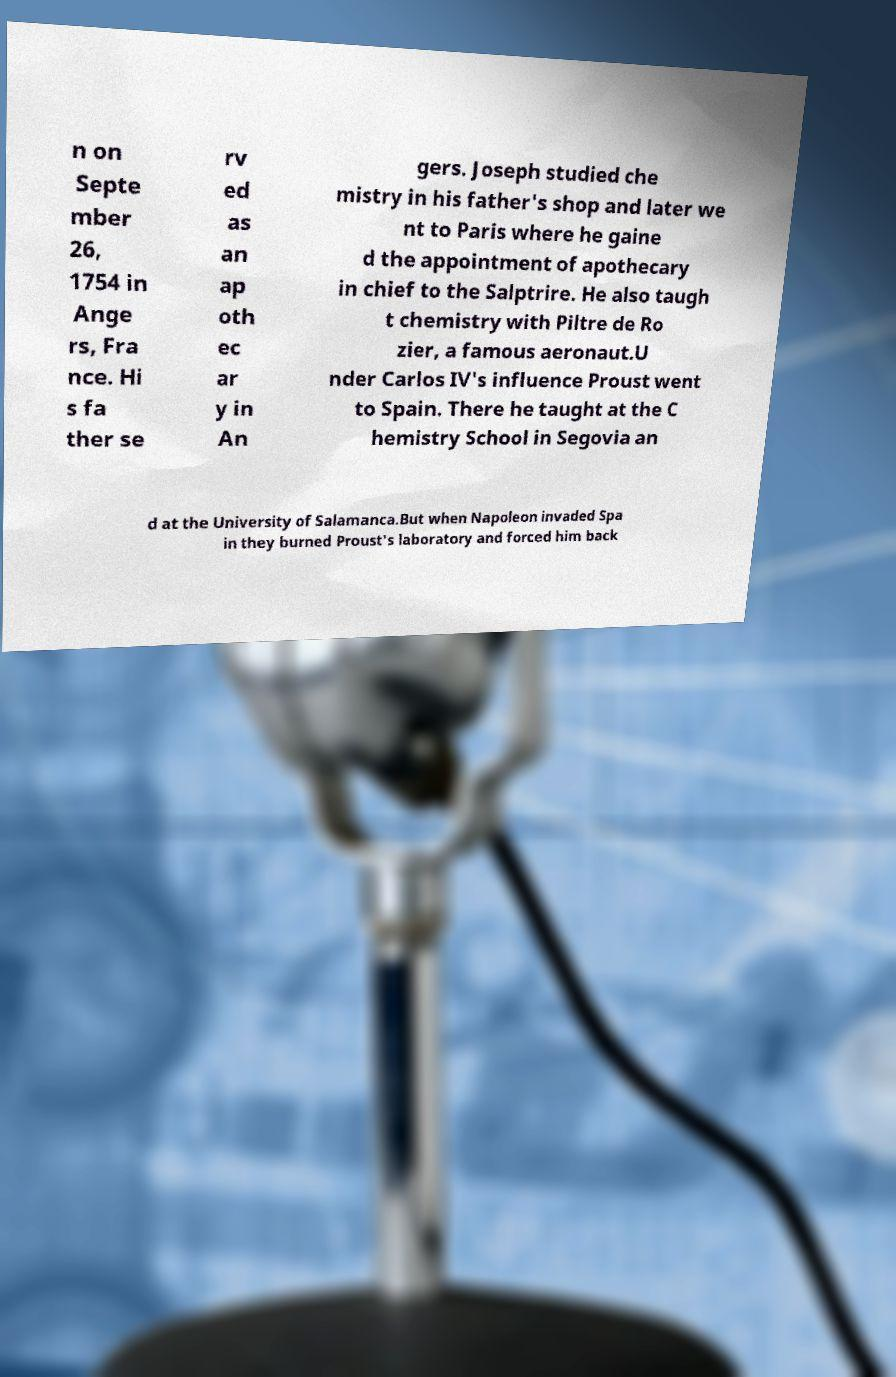Can you read and provide the text displayed in the image?This photo seems to have some interesting text. Can you extract and type it out for me? n on Septe mber 26, 1754 in Ange rs, Fra nce. Hi s fa ther se rv ed as an ap oth ec ar y in An gers. Joseph studied che mistry in his father's shop and later we nt to Paris where he gaine d the appointment of apothecary in chief to the Salptrire. He also taugh t chemistry with Piltre de Ro zier, a famous aeronaut.U nder Carlos IV's influence Proust went to Spain. There he taught at the C hemistry School in Segovia an d at the University of Salamanca.But when Napoleon invaded Spa in they burned Proust's laboratory and forced him back 